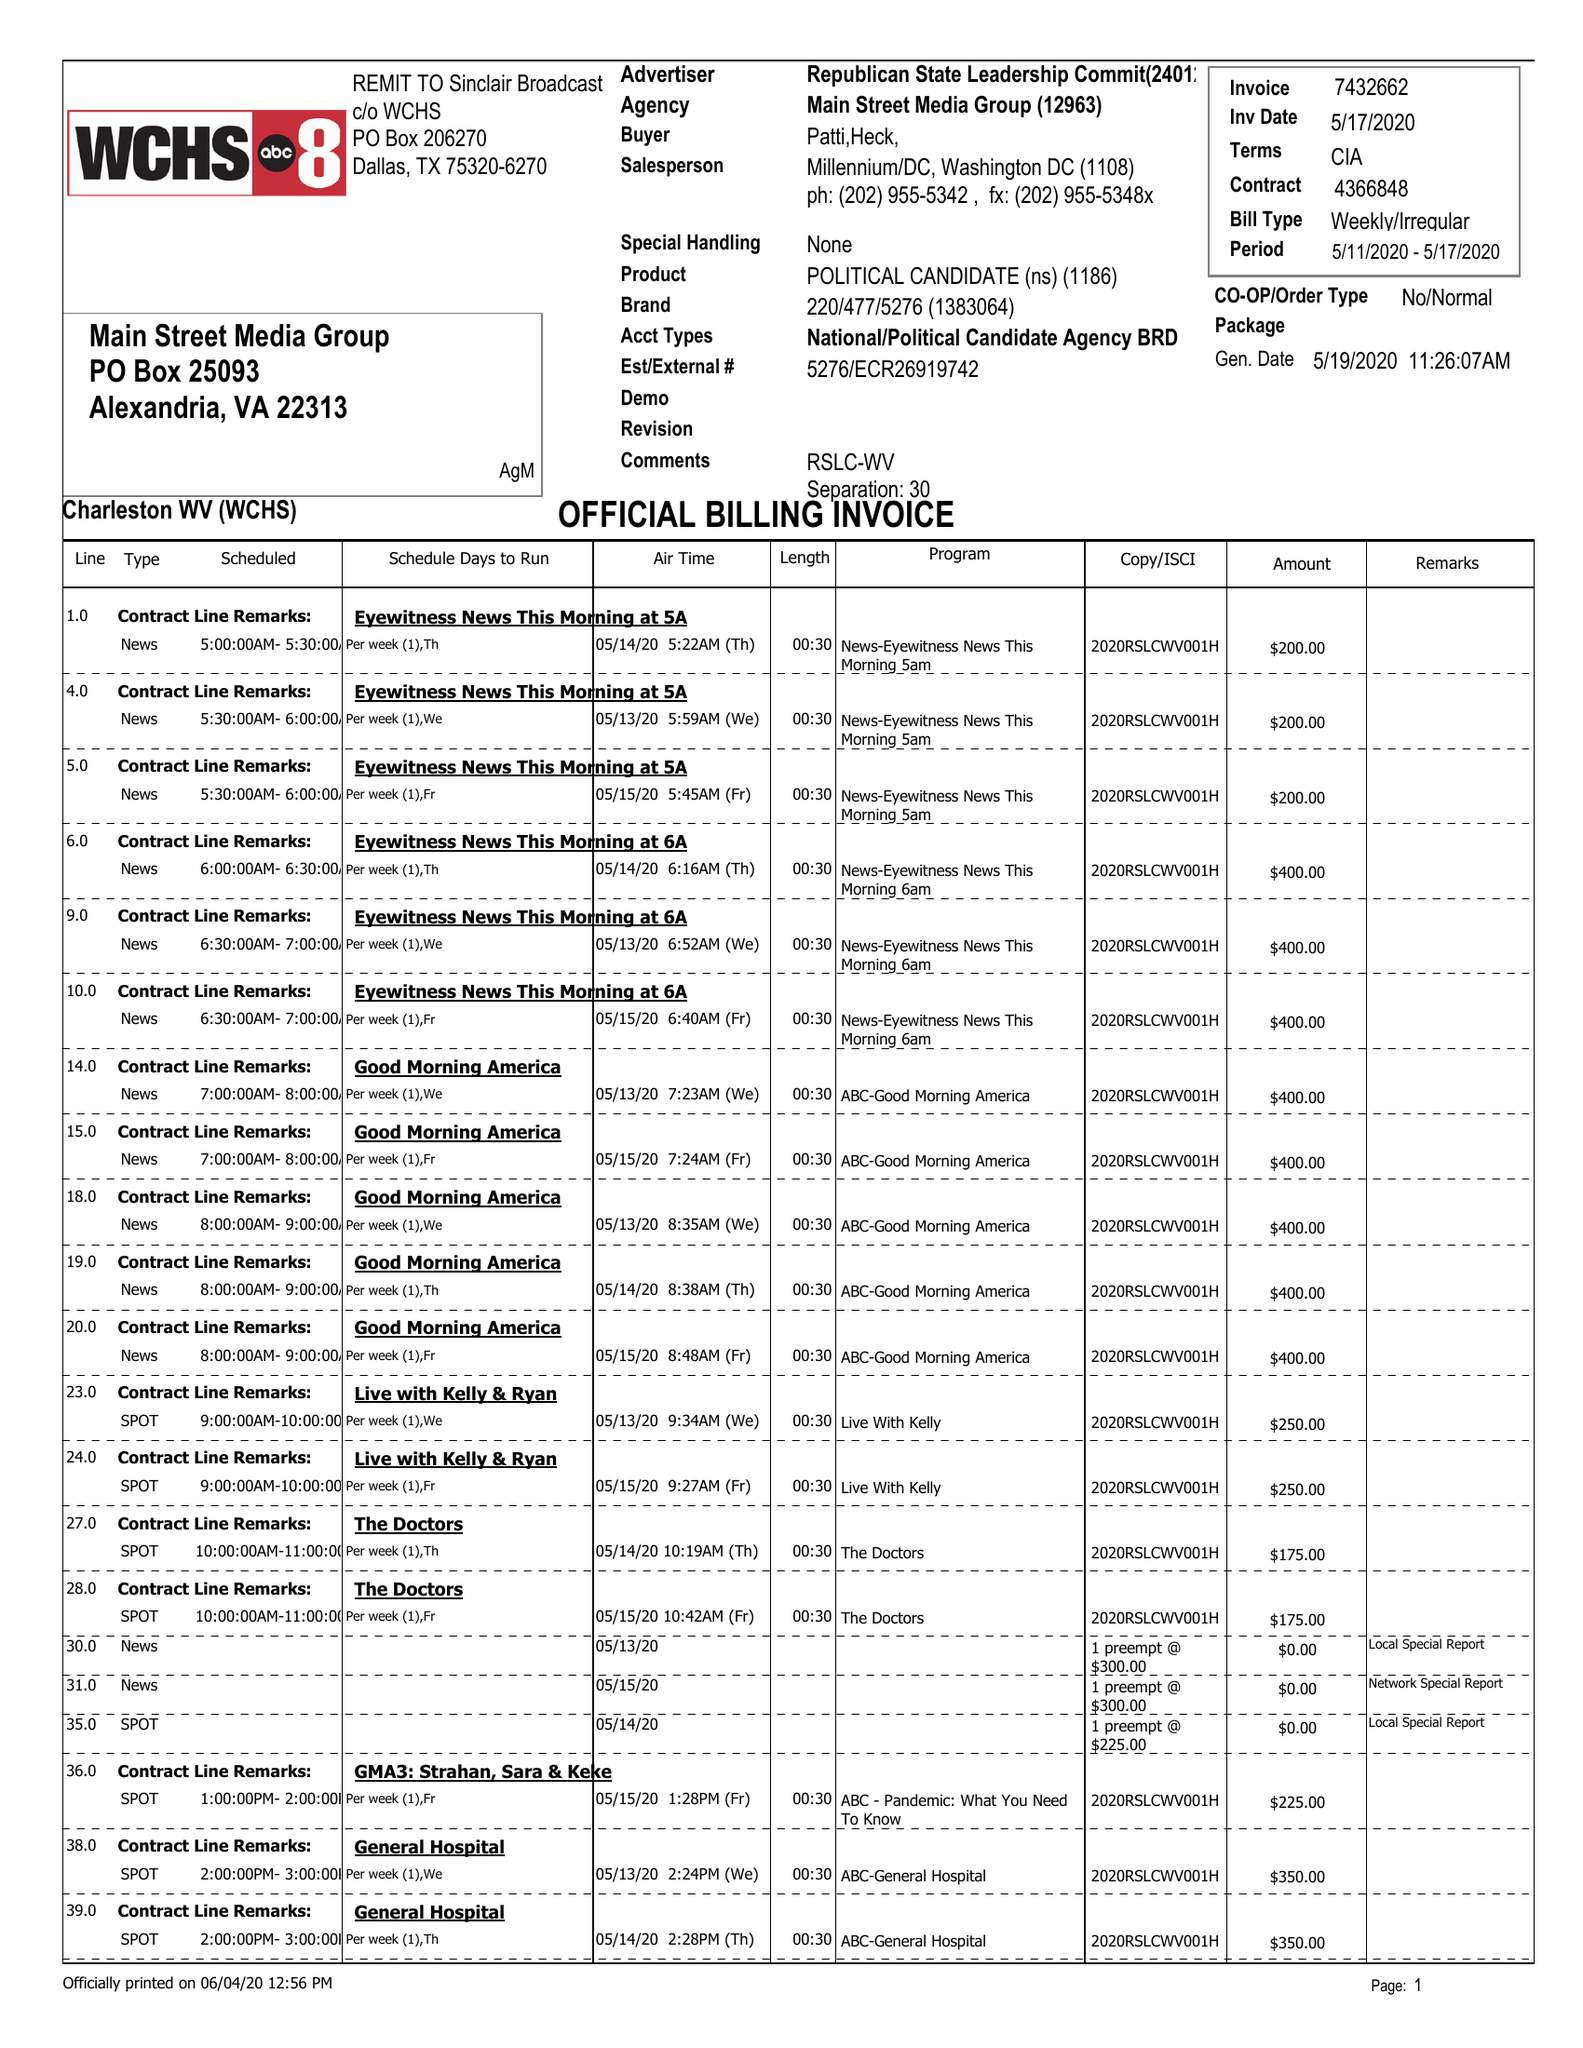What is the value for the flight_to?
Answer the question using a single word or phrase. 05/17/20 